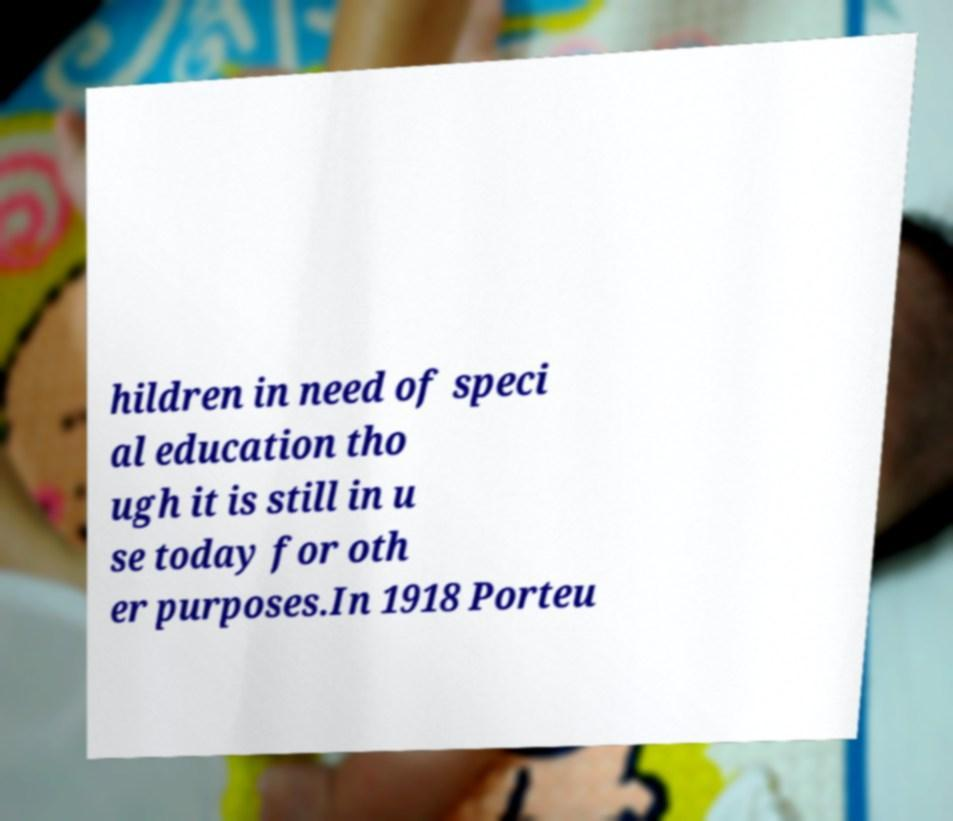I need the written content from this picture converted into text. Can you do that? hildren in need of speci al education tho ugh it is still in u se today for oth er purposes.In 1918 Porteu 